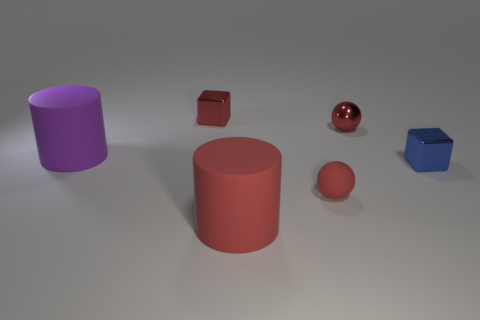There is a small red object that is in front of the blue shiny thing; does it have the same shape as the small red metal thing that is to the right of the small rubber sphere?
Provide a short and direct response. Yes. What is the material of the blue object?
Your answer should be compact. Metal. What material is the small ball that is behind the small matte object?
Offer a very short reply. Metal. Is there anything else that has the same color as the tiny matte thing?
Your answer should be compact. Yes. What is the size of the ball that is the same material as the big purple cylinder?
Your answer should be compact. Small. There is a cube that is in front of the big matte cylinder on the left side of the tiny metal thing to the left of the large red cylinder; what is its size?
Your response must be concise. Small. How many purple cylinders are the same size as the red rubber cylinder?
Make the answer very short. 1. Do the metallic sphere and the tiny matte ball have the same color?
Provide a succinct answer. Yes. What color is the other sphere that is the same size as the red metallic ball?
Offer a terse response. Red. There is a red metal thing left of the red metal ball; is it the same size as the thing that is to the right of the metallic ball?
Ensure brevity in your answer.  Yes. 